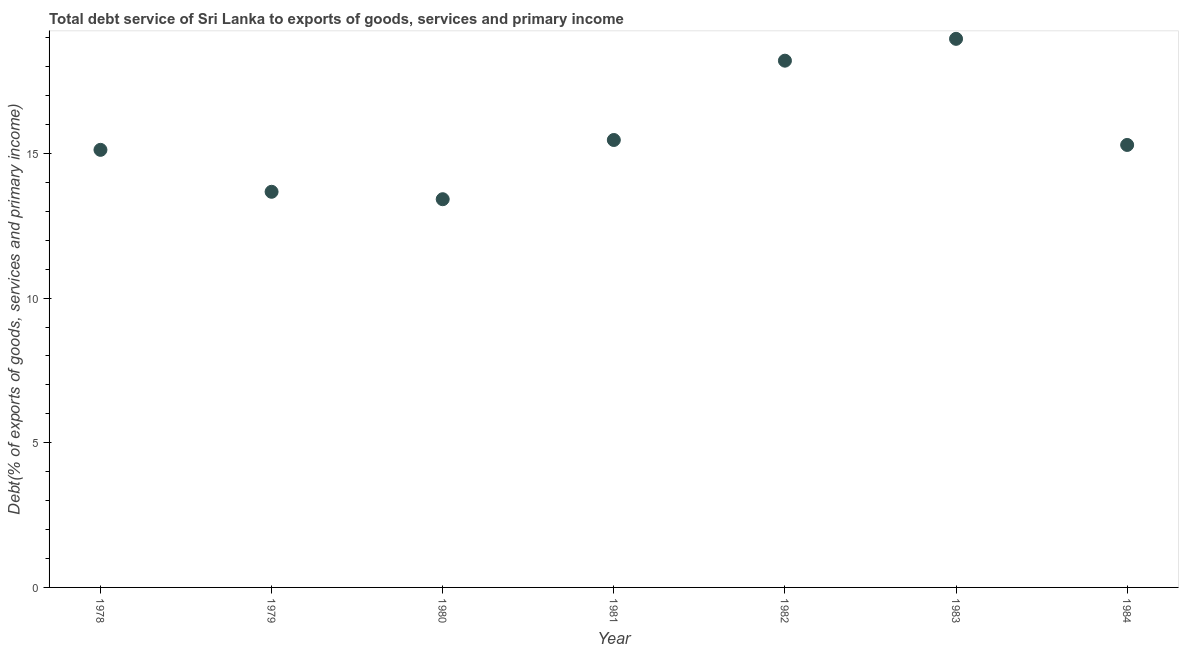What is the total debt service in 1984?
Offer a terse response. 15.29. Across all years, what is the maximum total debt service?
Give a very brief answer. 18.96. Across all years, what is the minimum total debt service?
Offer a terse response. 13.42. In which year was the total debt service minimum?
Provide a short and direct response. 1980. What is the sum of the total debt service?
Give a very brief answer. 110.13. What is the difference between the total debt service in 1980 and 1981?
Provide a succinct answer. -2.05. What is the average total debt service per year?
Ensure brevity in your answer.  15.73. What is the median total debt service?
Provide a short and direct response. 15.29. In how many years, is the total debt service greater than 5 %?
Ensure brevity in your answer.  7. What is the ratio of the total debt service in 1980 to that in 1984?
Make the answer very short. 0.88. Is the total debt service in 1978 less than that in 1984?
Make the answer very short. Yes. What is the difference between the highest and the second highest total debt service?
Provide a succinct answer. 0.75. Is the sum of the total debt service in 1980 and 1983 greater than the maximum total debt service across all years?
Provide a succinct answer. Yes. What is the difference between the highest and the lowest total debt service?
Your response must be concise. 5.54. Does the total debt service monotonically increase over the years?
Offer a very short reply. No. How many years are there in the graph?
Provide a short and direct response. 7. What is the difference between two consecutive major ticks on the Y-axis?
Your answer should be compact. 5. Are the values on the major ticks of Y-axis written in scientific E-notation?
Your answer should be compact. No. What is the title of the graph?
Provide a succinct answer. Total debt service of Sri Lanka to exports of goods, services and primary income. What is the label or title of the X-axis?
Provide a short and direct response. Year. What is the label or title of the Y-axis?
Give a very brief answer. Debt(% of exports of goods, services and primary income). What is the Debt(% of exports of goods, services and primary income) in 1978?
Offer a terse response. 15.12. What is the Debt(% of exports of goods, services and primary income) in 1979?
Keep it short and to the point. 13.67. What is the Debt(% of exports of goods, services and primary income) in 1980?
Keep it short and to the point. 13.42. What is the Debt(% of exports of goods, services and primary income) in 1981?
Offer a terse response. 15.46. What is the Debt(% of exports of goods, services and primary income) in 1982?
Offer a terse response. 18.2. What is the Debt(% of exports of goods, services and primary income) in 1983?
Offer a terse response. 18.96. What is the Debt(% of exports of goods, services and primary income) in 1984?
Provide a short and direct response. 15.29. What is the difference between the Debt(% of exports of goods, services and primary income) in 1978 and 1979?
Provide a succinct answer. 1.45. What is the difference between the Debt(% of exports of goods, services and primary income) in 1978 and 1980?
Your response must be concise. 1.71. What is the difference between the Debt(% of exports of goods, services and primary income) in 1978 and 1981?
Give a very brief answer. -0.34. What is the difference between the Debt(% of exports of goods, services and primary income) in 1978 and 1982?
Provide a short and direct response. -3.08. What is the difference between the Debt(% of exports of goods, services and primary income) in 1978 and 1983?
Your response must be concise. -3.84. What is the difference between the Debt(% of exports of goods, services and primary income) in 1978 and 1984?
Ensure brevity in your answer.  -0.17. What is the difference between the Debt(% of exports of goods, services and primary income) in 1979 and 1980?
Give a very brief answer. 0.26. What is the difference between the Debt(% of exports of goods, services and primary income) in 1979 and 1981?
Your response must be concise. -1.79. What is the difference between the Debt(% of exports of goods, services and primary income) in 1979 and 1982?
Provide a short and direct response. -4.53. What is the difference between the Debt(% of exports of goods, services and primary income) in 1979 and 1983?
Make the answer very short. -5.29. What is the difference between the Debt(% of exports of goods, services and primary income) in 1979 and 1984?
Provide a short and direct response. -1.62. What is the difference between the Debt(% of exports of goods, services and primary income) in 1980 and 1981?
Offer a terse response. -2.05. What is the difference between the Debt(% of exports of goods, services and primary income) in 1980 and 1982?
Ensure brevity in your answer.  -4.79. What is the difference between the Debt(% of exports of goods, services and primary income) in 1980 and 1983?
Offer a terse response. -5.54. What is the difference between the Debt(% of exports of goods, services and primary income) in 1980 and 1984?
Give a very brief answer. -1.88. What is the difference between the Debt(% of exports of goods, services and primary income) in 1981 and 1982?
Offer a terse response. -2.74. What is the difference between the Debt(% of exports of goods, services and primary income) in 1981 and 1983?
Your answer should be very brief. -3.5. What is the difference between the Debt(% of exports of goods, services and primary income) in 1981 and 1984?
Keep it short and to the point. 0.17. What is the difference between the Debt(% of exports of goods, services and primary income) in 1982 and 1983?
Ensure brevity in your answer.  -0.75. What is the difference between the Debt(% of exports of goods, services and primary income) in 1982 and 1984?
Your answer should be very brief. 2.91. What is the difference between the Debt(% of exports of goods, services and primary income) in 1983 and 1984?
Your response must be concise. 3.67. What is the ratio of the Debt(% of exports of goods, services and primary income) in 1978 to that in 1979?
Offer a terse response. 1.11. What is the ratio of the Debt(% of exports of goods, services and primary income) in 1978 to that in 1980?
Provide a succinct answer. 1.13. What is the ratio of the Debt(% of exports of goods, services and primary income) in 1978 to that in 1982?
Make the answer very short. 0.83. What is the ratio of the Debt(% of exports of goods, services and primary income) in 1978 to that in 1983?
Your answer should be compact. 0.8. What is the ratio of the Debt(% of exports of goods, services and primary income) in 1978 to that in 1984?
Make the answer very short. 0.99. What is the ratio of the Debt(% of exports of goods, services and primary income) in 1979 to that in 1980?
Offer a very short reply. 1.02. What is the ratio of the Debt(% of exports of goods, services and primary income) in 1979 to that in 1981?
Provide a short and direct response. 0.88. What is the ratio of the Debt(% of exports of goods, services and primary income) in 1979 to that in 1982?
Ensure brevity in your answer.  0.75. What is the ratio of the Debt(% of exports of goods, services and primary income) in 1979 to that in 1983?
Your answer should be compact. 0.72. What is the ratio of the Debt(% of exports of goods, services and primary income) in 1979 to that in 1984?
Ensure brevity in your answer.  0.89. What is the ratio of the Debt(% of exports of goods, services and primary income) in 1980 to that in 1981?
Make the answer very short. 0.87. What is the ratio of the Debt(% of exports of goods, services and primary income) in 1980 to that in 1982?
Your response must be concise. 0.74. What is the ratio of the Debt(% of exports of goods, services and primary income) in 1980 to that in 1983?
Provide a short and direct response. 0.71. What is the ratio of the Debt(% of exports of goods, services and primary income) in 1980 to that in 1984?
Offer a terse response. 0.88. What is the ratio of the Debt(% of exports of goods, services and primary income) in 1981 to that in 1982?
Your response must be concise. 0.85. What is the ratio of the Debt(% of exports of goods, services and primary income) in 1981 to that in 1983?
Your answer should be very brief. 0.82. What is the ratio of the Debt(% of exports of goods, services and primary income) in 1982 to that in 1984?
Offer a terse response. 1.19. What is the ratio of the Debt(% of exports of goods, services and primary income) in 1983 to that in 1984?
Your answer should be compact. 1.24. 